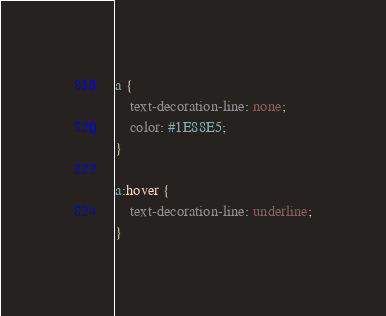Convert code to text. <code><loc_0><loc_0><loc_500><loc_500><_CSS_>a {
	text-decoration-line: none;
	color: #1E88E5;
}

a:hover {
	text-decoration-line: underline;
}
</code> 